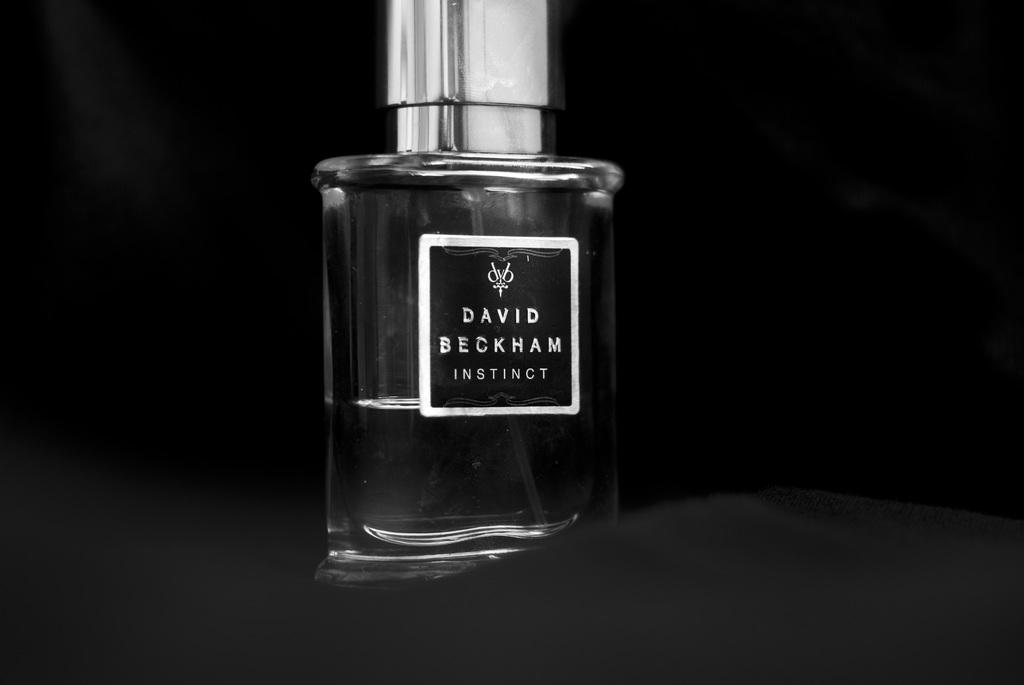Provide a one-sentence caption for the provided image. A bottle of David Beckham Instinct Cologne with a black background. 